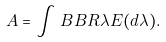<formula> <loc_0><loc_0><loc_500><loc_500>A = \int _ { \ } B B { R } \lambda E ( d \lambda ) .</formula> 